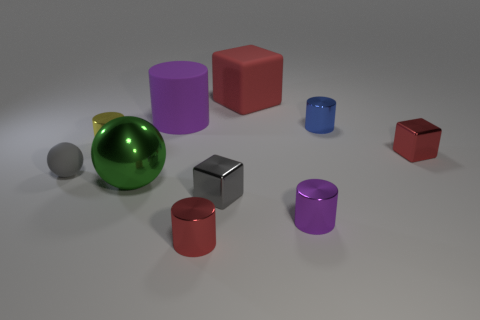There is a small metallic cube on the left side of the blue shiny object; how many red shiny cylinders are behind it?
Offer a terse response. 0. Is there another large thing that has the same shape as the big purple rubber thing?
Give a very brief answer. No. Do the small red metallic object on the left side of the small purple metallic thing and the tiny red metallic thing right of the red metallic cylinder have the same shape?
Make the answer very short. No. How many things are tiny yellow cylinders or large purple matte cylinders?
Your answer should be compact. 2. The blue metal thing that is the same shape as the large purple rubber thing is what size?
Provide a short and direct response. Small. Are there more metallic objects that are behind the small red shiny cylinder than small red matte cubes?
Make the answer very short. Yes. Does the tiny red block have the same material as the small gray ball?
Your answer should be compact. No. What number of things are either red metal objects on the left side of the red metal block or metallic objects that are left of the large purple matte thing?
Make the answer very short. 3. What color is the shiny object that is the same shape as the gray matte thing?
Offer a very short reply. Green. What number of shiny cylinders have the same color as the matte block?
Ensure brevity in your answer.  1. 